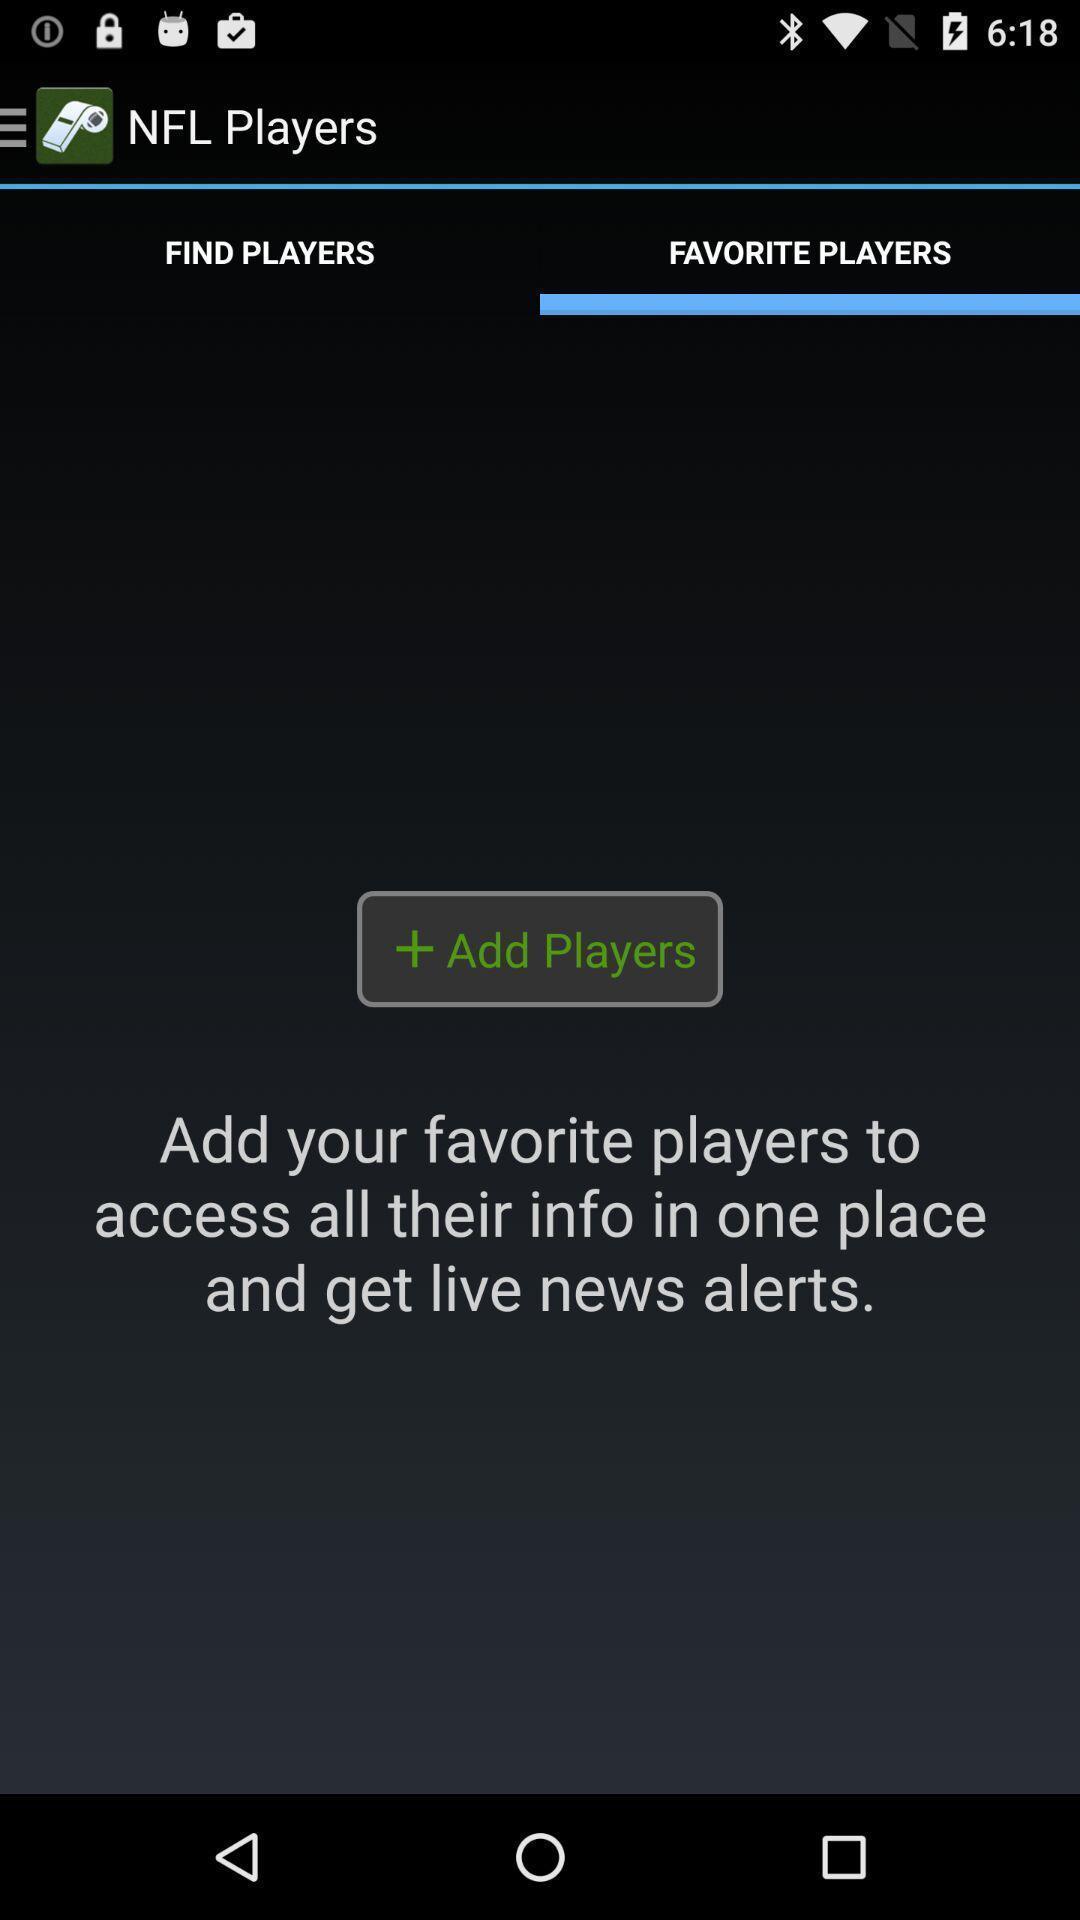Provide a textual representation of this image. Screen displaying the page of favorite players which is empty. 